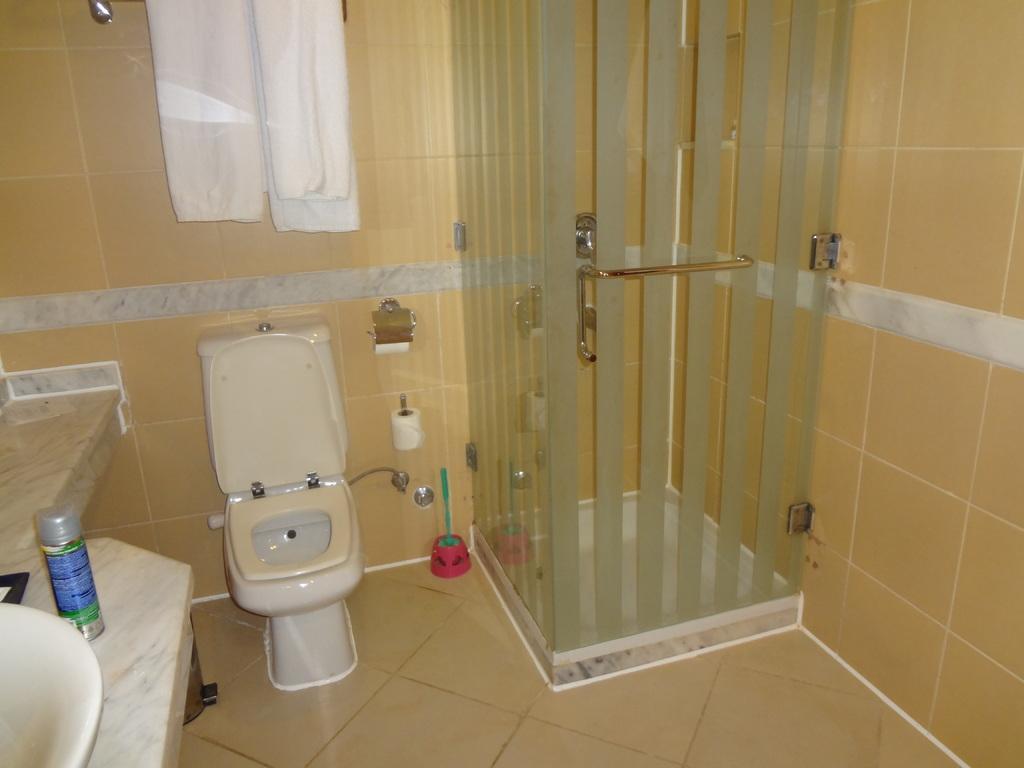Please provide a concise description of this image. In this image we can see a toilet and a glass door. Behind the toilet we can see a wall and on the wall we can clothes, tap and a paper. On the right side, we can see a wall. On the left, we can see few objects on a shelf. We can see an object on the floor. 